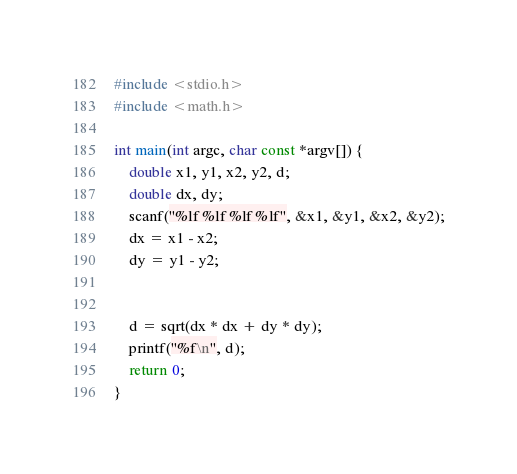<code> <loc_0><loc_0><loc_500><loc_500><_C_>#include <stdio.h>
#include <math.h>

int main(int argc, char const *argv[]) {
    double x1, y1, x2, y2, d;
    double dx, dy;
    scanf("%lf %lf %lf %lf", &x1, &y1, &x2, &y2);
    dx = x1 - x2;
    dy = y1 - y2;


    d = sqrt(dx * dx + dy * dy);
    printf("%f\n", d);
    return 0;
}
</code> 